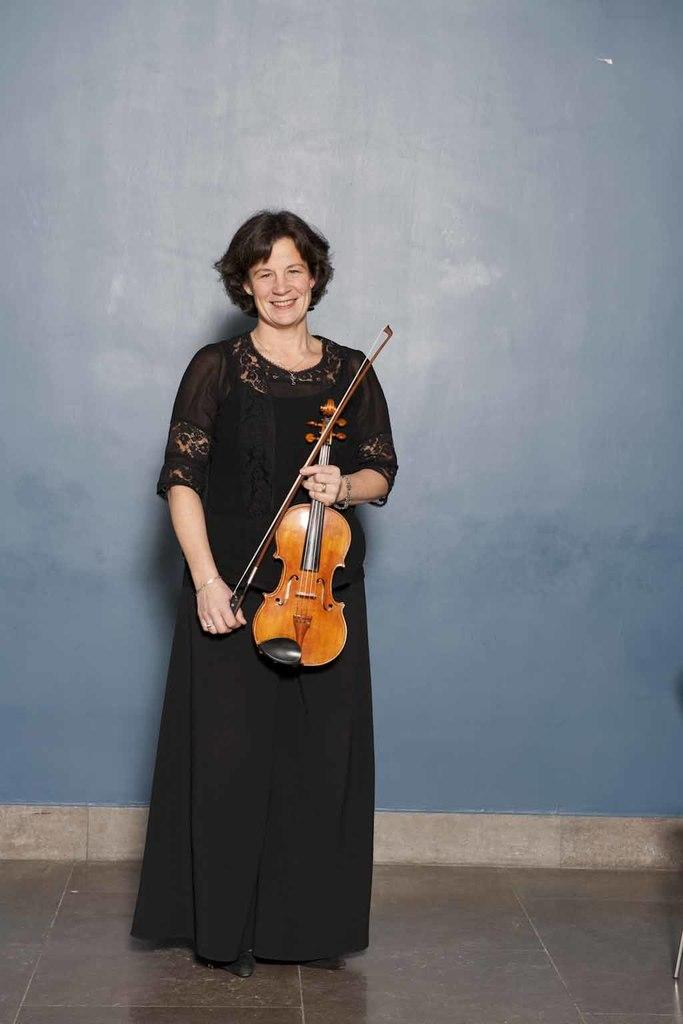Who is the main subject in the image? There is a lady in the image. What is the lady holding in the image? The lady is holding a violin. Where is the lady located in the image? The lady is in the foreground area of the image. What can be seen in the background of the image? There is a wall in the background of the image. What type of button is the lady wearing on her shirt in the image? There is no button visible on the lady's shirt in the image. Can you tell me who the parent of the lady is in the image? There is no information about the lady's parent in the image. --- Facts: 1. There is a car in the image. 2. The car is parked on the street. 3. There are trees on both sides of the street. 4. The sky is visible in the image. 5. There is a traffic light in the image. Absurd Topics: elephant, ocean, volcano Conversation: What is the main subject in the image? There is a car in the image. Where is the car located in the image? The car is parked on the street. What can be seen on both sides of the street? There are trees on both sides of the street. What is visible in the image besides the car and trees? The sky is visible in the image. What might help regulate traffic in the image? There is a traffic light in the image. Reasoning: Let's think step by step in order to produce the conversation. We start by identifying the main subject in the image, which is the car. Then, we describe the car's location, which is parked on the street. Next, we mention the presence of trees on both sides of the street. We then acknowledge the presence of the sky in the image. Finally, we describe the traffic light, which might help regulate traffic. Absurd Question/Answer: Can you tell me how many elephants are swimming in the ocean in the image? There are no elephants or ocean present in the image. Is there a volcano erupting in the background of the image? There is no volcano present in the image. 